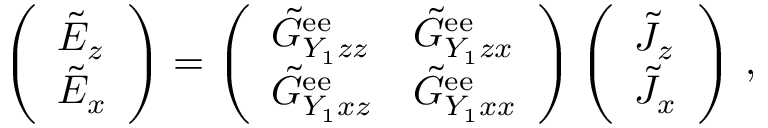Convert formula to latex. <formula><loc_0><loc_0><loc_500><loc_500>\left ( \begin{array} { l } { \tilde { E } _ { z } } \\ { \tilde { E } _ { x } } \end{array} \right ) = \left ( \begin{array} { l l } { \tilde { G } _ { Y _ { 1 } z z } ^ { e e } } & { \tilde { G } _ { Y _ { 1 } z x } ^ { e e } } \\ { \tilde { G } _ { Y _ { 1 } x z } ^ { e e } } & { \tilde { G } _ { Y _ { 1 } x x } ^ { e e } } \end{array} \right ) \left ( \begin{array} { l } { \tilde { J } _ { z } } \\ { \tilde { J } _ { x } } \end{array} \right ) \, ,</formula> 